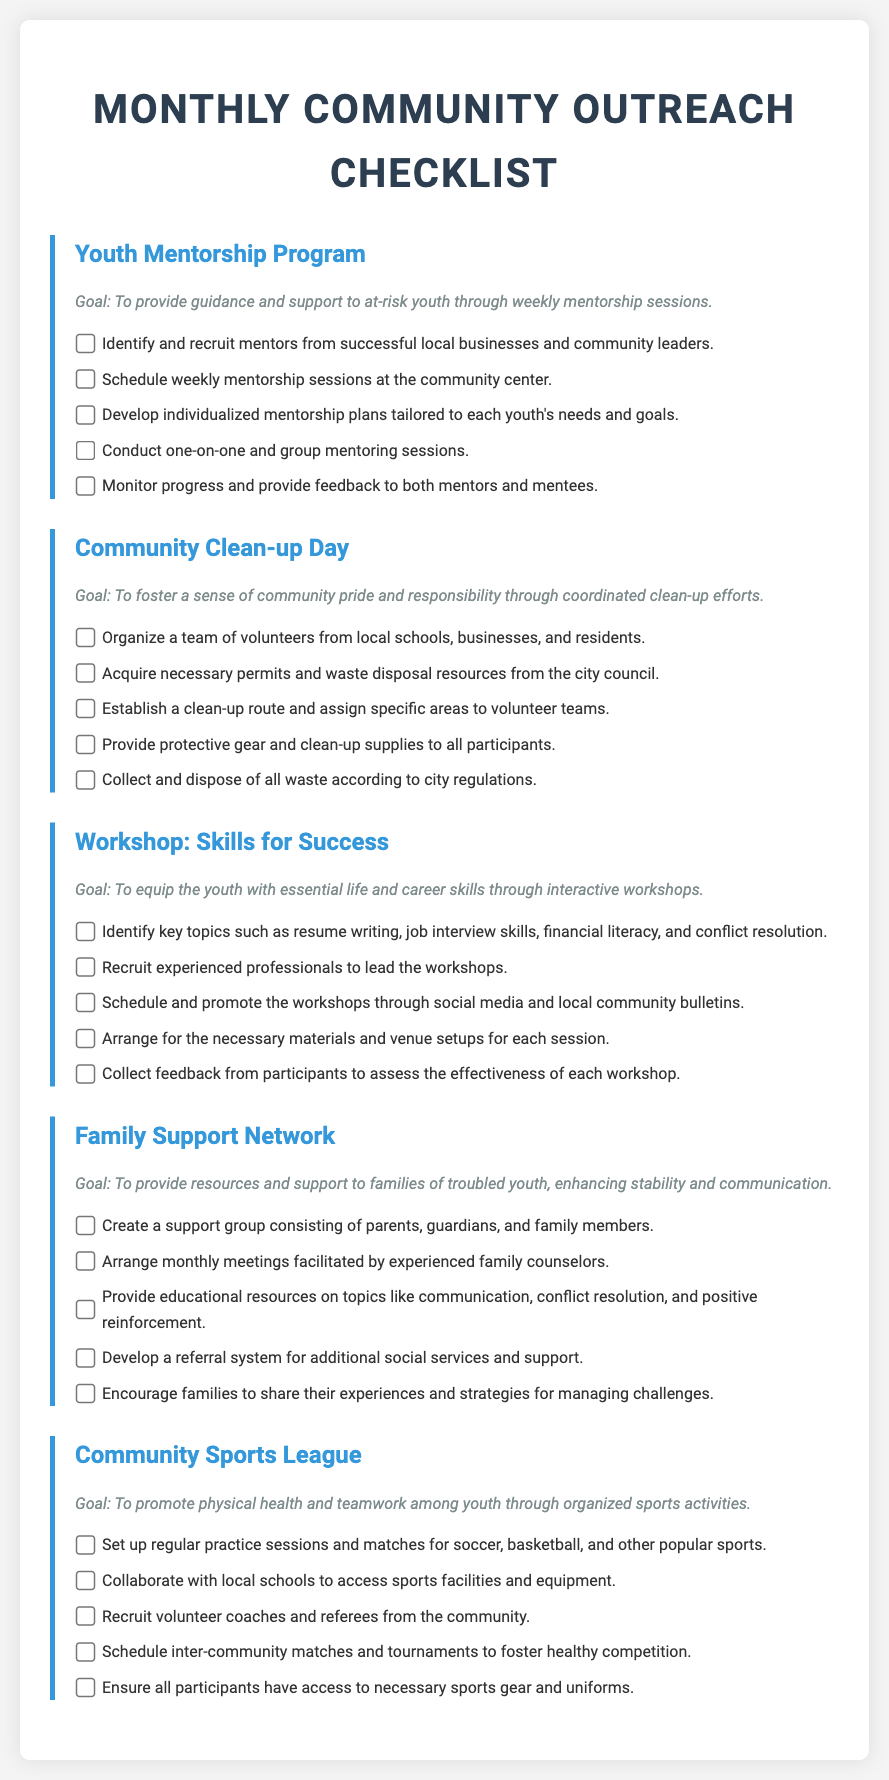What is the goal of the Youth Mentorship Program? The goal of the Youth Mentorship Program is to provide guidance and support to at-risk youth through weekly mentorship sessions.
Answer: To provide guidance and support to at-risk youth through weekly mentorship sessions How many tasks are listed for the Community Clean-up Day? The Community Clean-up Day section includes five specific tasks to complete.
Answer: 5 What are the key topics identified for the Skills for Success workshop? The document specifies resume writing, job interview skills, financial literacy, and conflict resolution as key topics.
Answer: Resume writing, job interview skills, financial literacy, conflict resolution Who should lead the Skills for Success workshops? The workshops should be led by experienced professionals as per the document.
Answer: Experienced professionals What is required to ensure all participants have for the Community Sports League? The document states that all participants must have access to necessary sports gear and uniforms.
Answer: Necessary sports gear and uniforms What is the main goal of the Family Support Network? The main goal is to provide resources and support to families of troubled youth, enhancing stability and communication.
Answer: To provide resources and support to families of troubled youth, enhancing stability and communication 